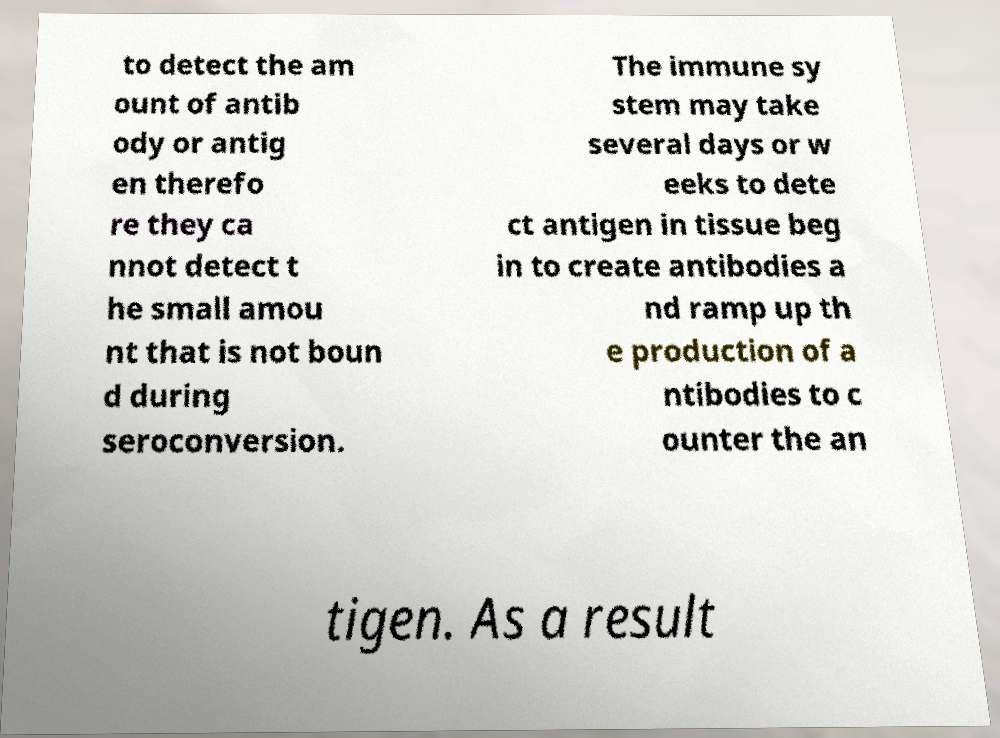What messages or text are displayed in this image? I need them in a readable, typed format. to detect the am ount of antib ody or antig en therefo re they ca nnot detect t he small amou nt that is not boun d during seroconversion. The immune sy stem may take several days or w eeks to dete ct antigen in tissue beg in to create antibodies a nd ramp up th e production of a ntibodies to c ounter the an tigen. As a result 